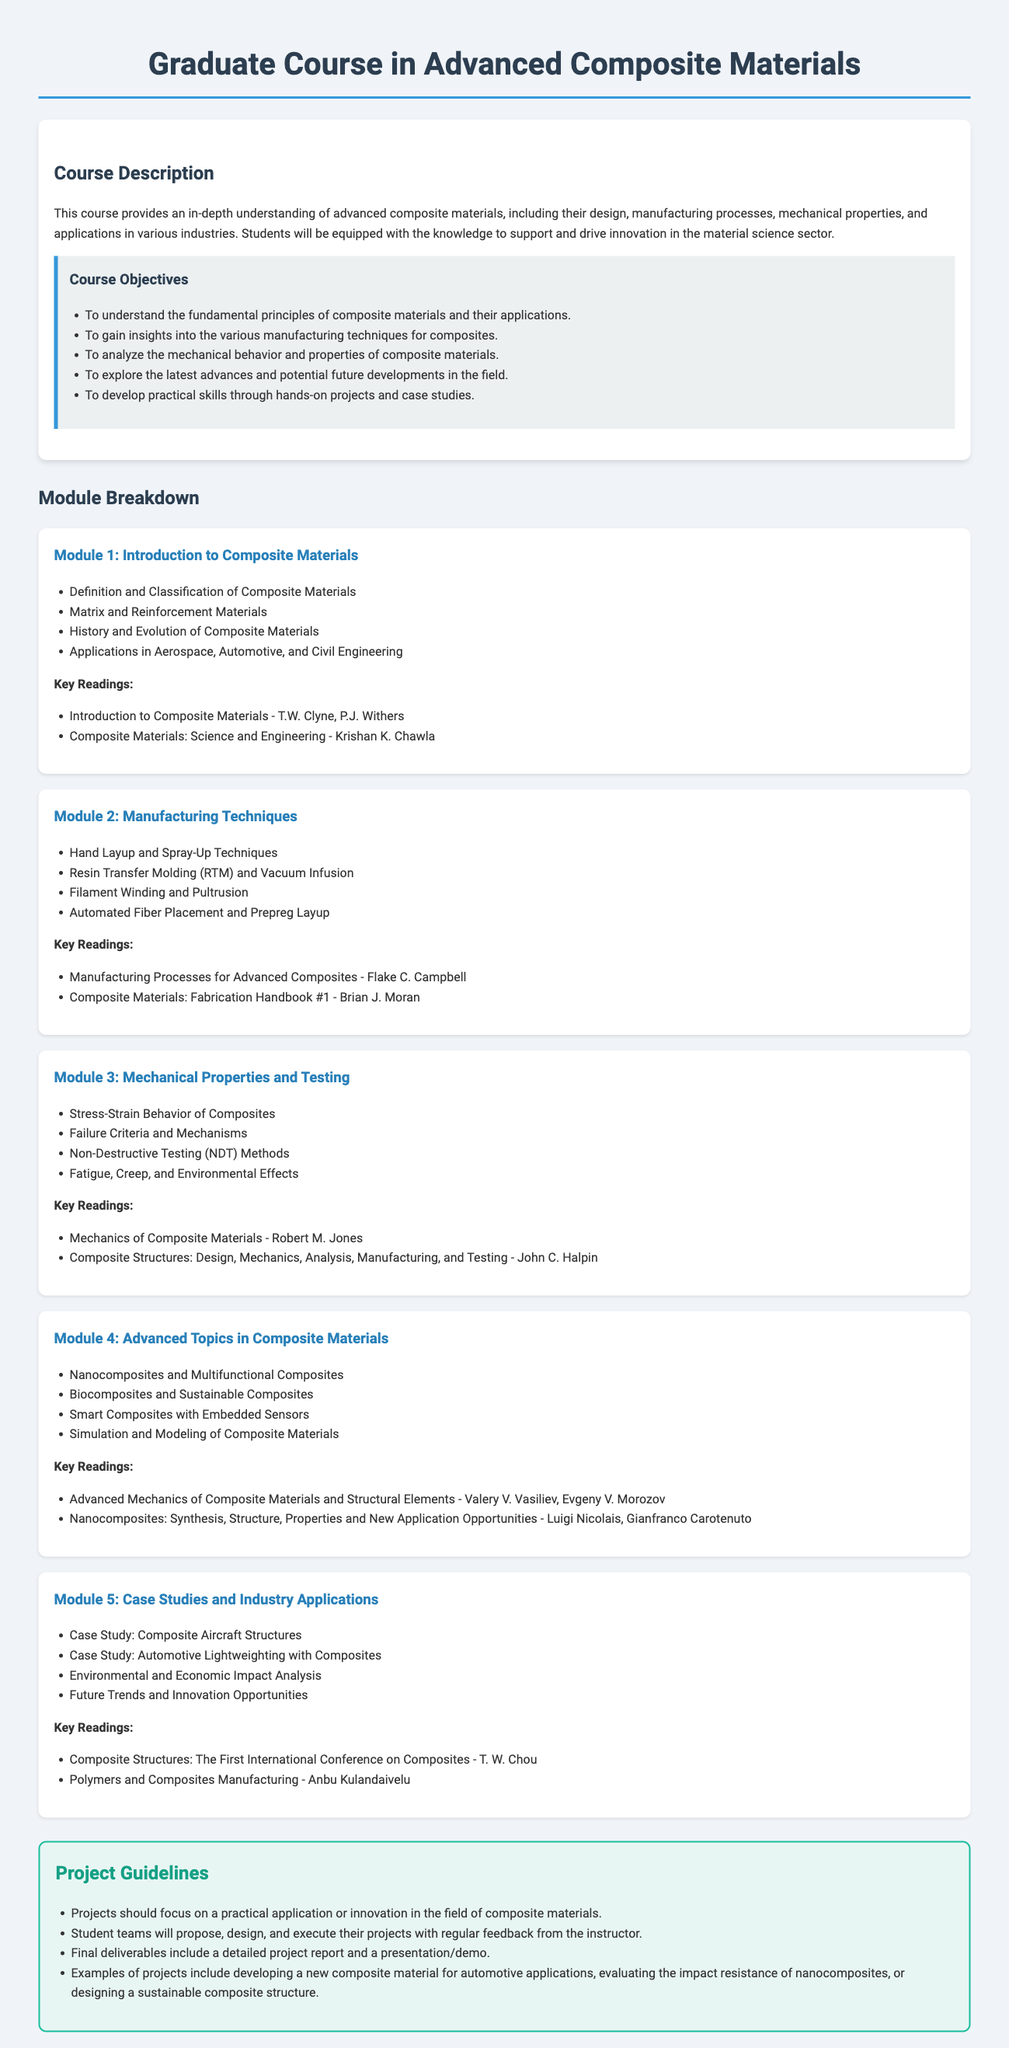What is the title of the course? The title of the course is provided at the top of the document, stated clearly as "Graduate Course in Advanced Composite Materials."
Answer: Graduate Course in Advanced Composite Materials How many modules are included in the syllabus? The syllabus explicitly lists five modules in the breakdown section, indicating the total count of modules.
Answer: 5 Who is the author of "Composite Materials: Science and Engineering"? This book is listed under the key readings of Module 1, authored by Krishan K. Chawla.
Answer: Krishan K. Chawla What is a key focus of the project guidelines? The project guidelines emphasize practical application or innovation, which is crucial for student projects.
Answer: Practical application or innovation Which module covers Nanocomposites? The advanced topics involving Nanocomposites are presented in Module 4, focusing on advanced materials.
Answer: Module 4 What is the purpose of the course according to its objectives? One of the objectives specifies equipping students with knowledge to drive innovation in the material science sector, indicating the course's purpose.
Answer: Drive innovation in the material science sector Name one manufacturing technique mentioned in Module 2. The syllabus includes various manufacturing techniques, one of which is Resin Transfer Molding (RTM).
Answer: Resin Transfer Molding (RTM) What is a case study topic discussed in Module 5? Module 5 discusses several case studies, one of which is Composite Aircraft Structures, highlighting practical applications of the course material.
Answer: Composite Aircraft Structures 